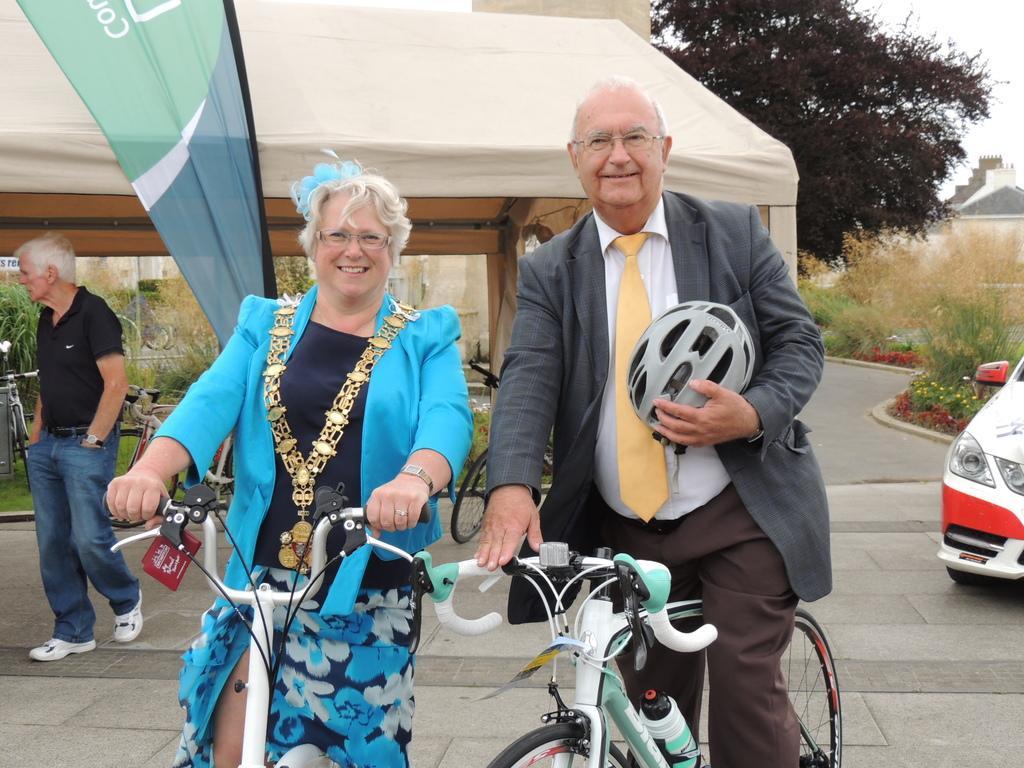Please provide a concise description of this image. This picture shows a woman and a man on a bicycle. Man is holding helmet in his hand. He is wearing spectacles. In the background, there is another man walking. We can see a fabric roof in the background and some trees here. There is a car on the right side. Behind the car there are some plants here. 